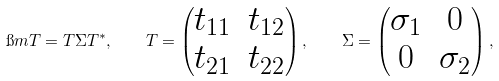Convert formula to latex. <formula><loc_0><loc_0><loc_500><loc_500>\i m T = T \Sigma T ^ { * } , \quad T = \begin{pmatrix} t _ { 1 1 } & t _ { 1 2 } \\ t _ { 2 1 } & t _ { 2 2 } \end{pmatrix} , \quad \Sigma = \begin{pmatrix} \sigma _ { 1 } & 0 \\ 0 & \sigma _ { 2 } \end{pmatrix} ,</formula> 